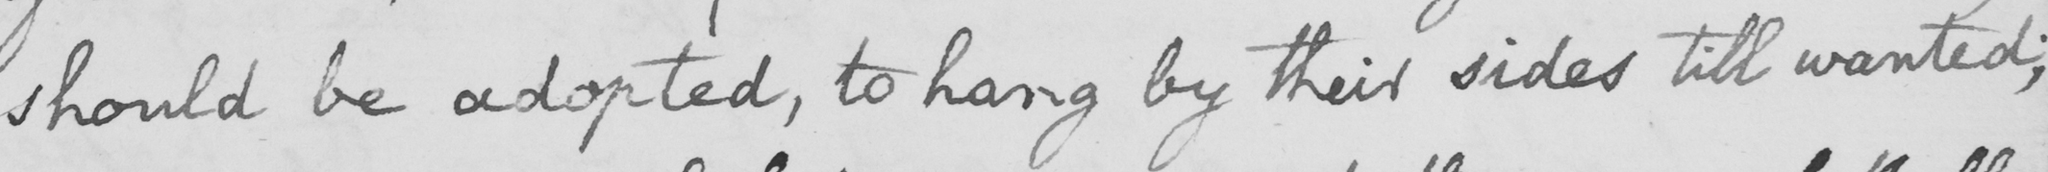Please provide the text content of this handwritten line. should be adopted , to hang by their sides till wanted ; 